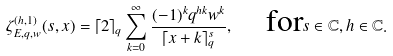<formula> <loc_0><loc_0><loc_500><loc_500>\zeta _ { E , q , w } ^ { ( h , 1 ) } ( s , x ) = \lceil 2 \rceil _ { q } \sum _ { k = 0 } ^ { \infty } \frac { ( - 1 ) ^ { k } q ^ { h k } w ^ { k } } { \lceil x + k \rceil _ { q } ^ { s } } , \quad \text {for} s \in \mathbb { C } , h \in \mathbb { C } .</formula> 